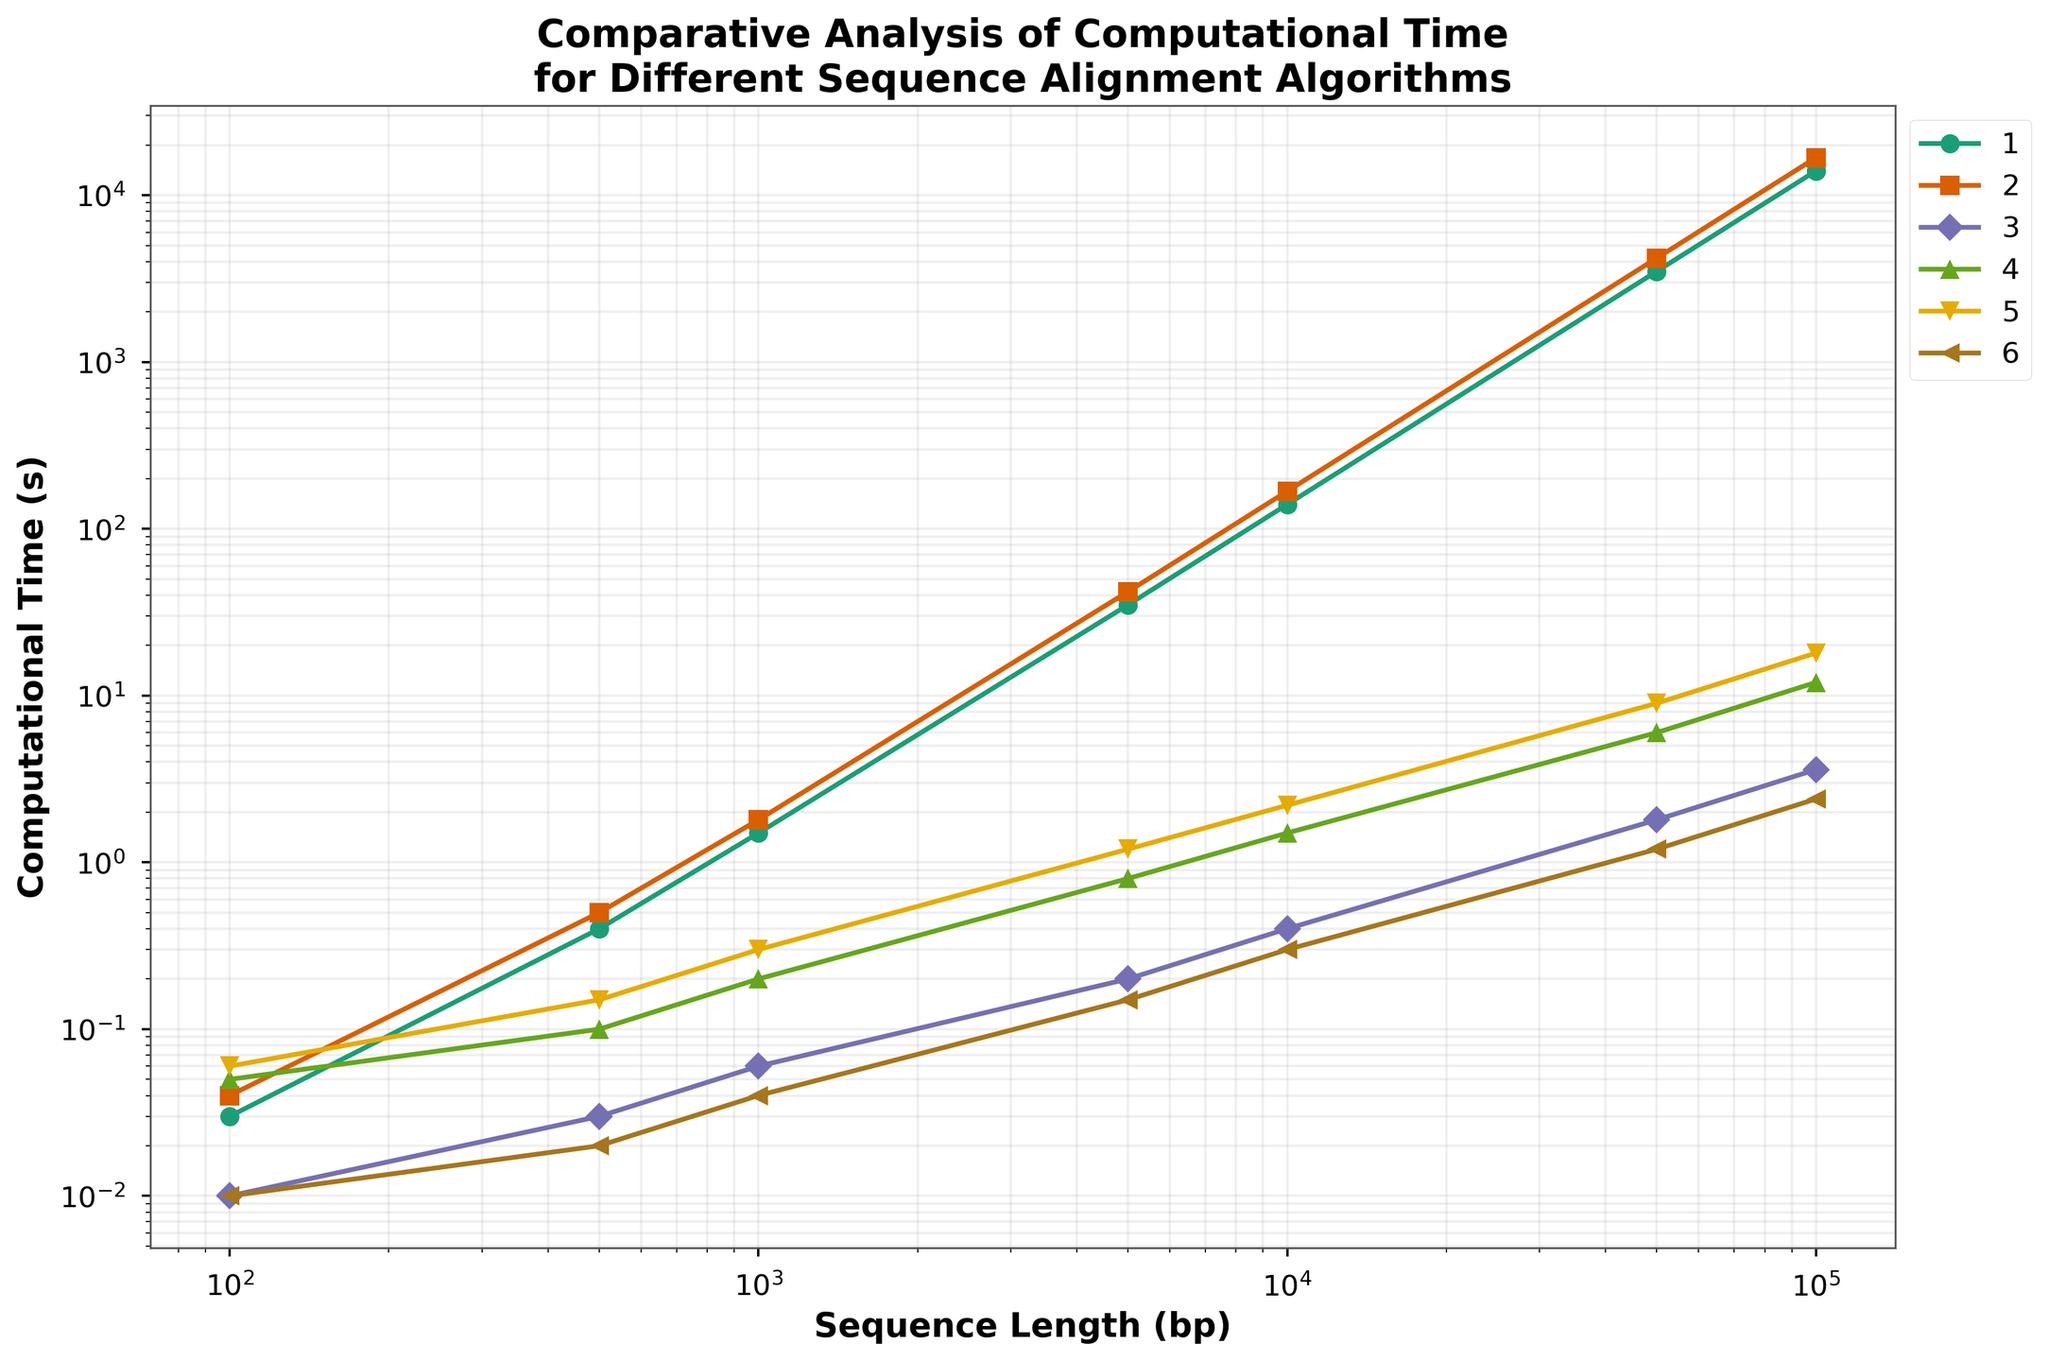What's the computational time for BLAST for a sequence length of 50000bp? Refer to the BLAST data series and find the value corresponding to a sequence length of 50000bp, which is 2.5 seconds.
Answer: 2.5 seconds Which algorithm has the shortest computational time for a sequence length of 1000bp? Compare the computational times for each algorithm at 1000bp. The shortest time is provided by Bowtie2, which is 0.04 seconds.
Answer: Bowtie2 What is the computational time difference between Needleman-Wunsch and Smith-Waterman for a sequence length of 5000bp? Find the values for Needleman-Wunsch and Smith-Waterman at 5000bp, which are 35 and 42 seconds, respectively. The difference is 42 - 35 = 7 seconds.
Answer: 7 seconds Which algorithm's computational time increases the most between 100bp and 10000bp? Calculate the increase for each algorithm between 100bp and 10000bp. Smith-Waterman increases from 0.04 to 168 seconds, an increase of 167.96 seconds, which is the largest increase.
Answer: Smith-Waterman At 100000bp, which algorithm has the computational time closest to 5 seconds? Check the computational times for each algorithm at 100000bp and compare them to 5 seconds. BLAST has a time of 5.2 seconds, which is closest.
Answer: BLAST Which algorithm shows a log-linear trend across all sequence lengths? Look at the consistency of the slopes in the log-log plot for each algorithm. Bowtie2 shows a consistent log-linear trend across all sequence lengths.
Answer: Bowtie2 For sequence lengths of 5000bp, which algorithm's computational time is double that of FASTA? Find FASTA's computational time at 5000bp, which is 0.2 seconds. The closest double value is 0.4 seconds. MAFFT shows 0.8 seconds, which is double.
Answer: MAFFT If the sequence length increases tenfold from 1000bp to 10000bp, by how many seconds does Clustal Omega's computational time increase? Clustal Omega's time at 1000bp is 0.3 seconds, and at 10000bp is 2.2 seconds. The increase is 2.2 - 0.3 = 1.9 seconds.
Answer: 1.9 seconds 